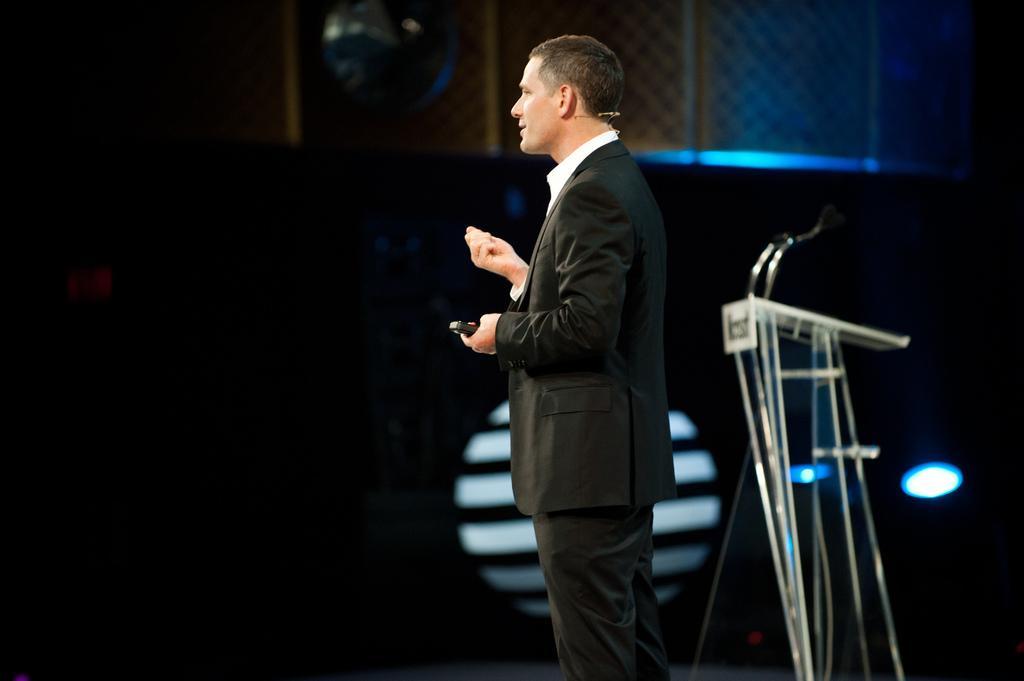In one or two sentences, can you explain what this image depicts? In the picture we can see a man standing and giving a speech and he is wearing a black color blazer with white shirt and behind him we can see a microphone stand and in the background we can see a wall with a blue color light focus to it. 